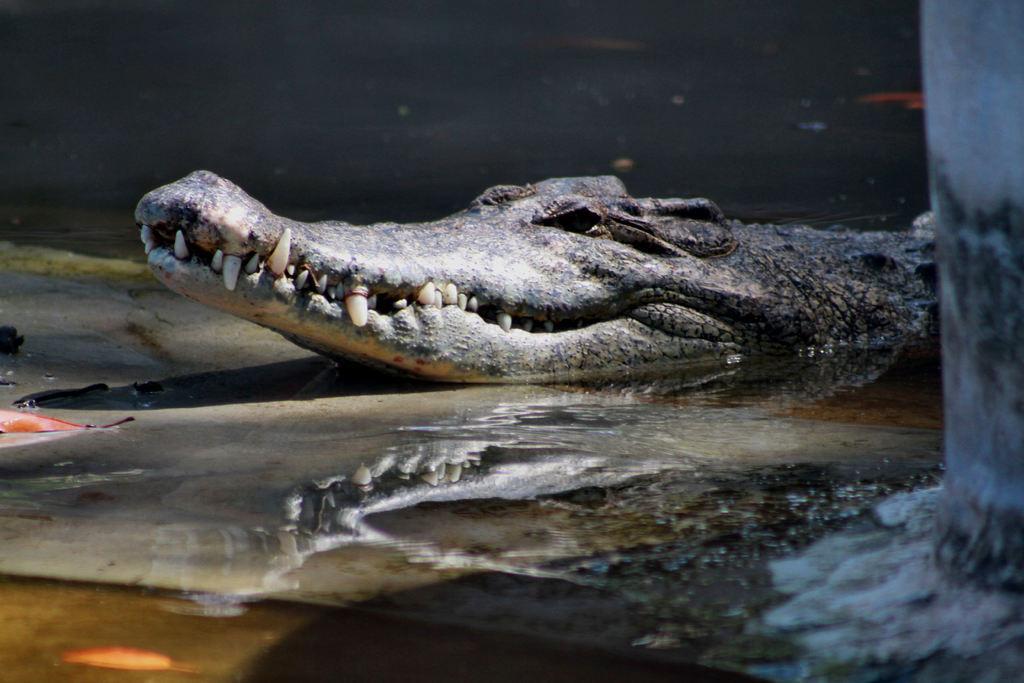Please provide a concise description of this image. In this image, we can see a crocodile in the water. 